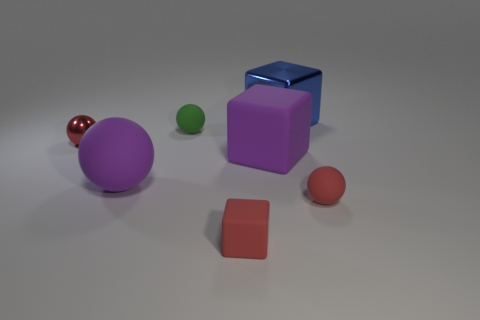Subtract all purple cylinders. How many red balls are left? 2 Subtract all purple matte blocks. How many blocks are left? 2 Add 3 tiny rubber blocks. How many objects exist? 10 Subtract all purple balls. How many balls are left? 3 Subtract 1 balls. How many balls are left? 3 Subtract all blocks. How many objects are left? 4 Subtract all tiny cyan matte cubes. Subtract all metallic spheres. How many objects are left? 6 Add 6 matte cubes. How many matte cubes are left? 8 Add 4 yellow shiny cubes. How many yellow shiny cubes exist? 4 Subtract 1 purple blocks. How many objects are left? 6 